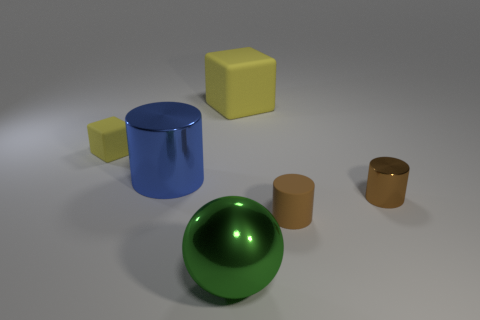Add 4 green rubber cubes. How many objects exist? 10 Subtract all cubes. How many objects are left? 4 Subtract all small metal cylinders. Subtract all brown objects. How many objects are left? 3 Add 6 large blocks. How many large blocks are left? 7 Add 3 yellow rubber cubes. How many yellow rubber cubes exist? 5 Subtract 0 red spheres. How many objects are left? 6 